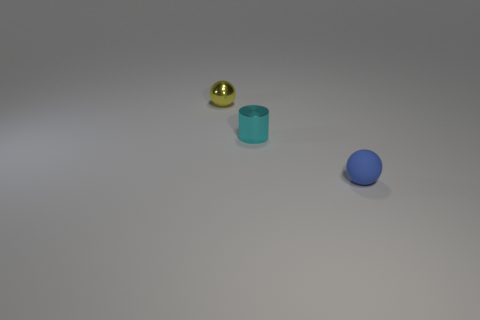There is a metallic thing that is the same size as the cylinder; what color is it?
Keep it short and to the point. Yellow. Is the shape of the tiny blue thing the same as the metallic object that is left of the small cylinder?
Give a very brief answer. Yes. What material is the tiny ball in front of the tiny ball that is behind the tiny sphere right of the yellow sphere?
Provide a succinct answer. Rubber. How many tiny objects are brown metal cylinders or rubber objects?
Ensure brevity in your answer.  1. What number of other objects are the same size as the yellow metal ball?
Provide a succinct answer. 2. There is a metal thing that is in front of the tiny metallic ball; is it the same shape as the small blue rubber thing?
Keep it short and to the point. No. There is another object that is the same shape as the small blue object; what is its color?
Give a very brief answer. Yellow. Are there any other things that have the same shape as the small cyan shiny object?
Give a very brief answer. No. Are there an equal number of small objects that are to the left of the tiny blue matte thing and small metallic things?
Offer a very short reply. Yes. How many things are both in front of the yellow shiny object and behind the tiny blue sphere?
Make the answer very short. 1. 